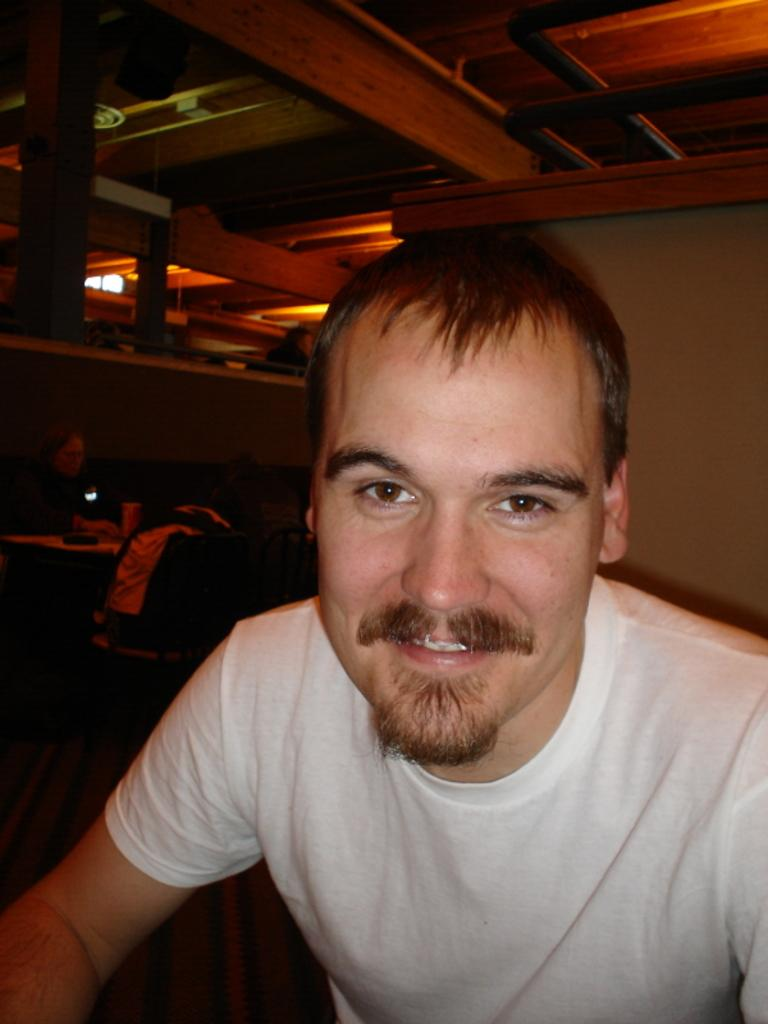What is the man in the image doing? The man in the image is smiling. What is the other person in the image doing? The other person is sitting in front of a table. What piece of furniture is present in the image? There is a bench in the image. What object can be seen in the image that might be used for carrying items? There is a bag in the image. What type of cow can be seen grazing in the background of the image? There is no cow present in the image; it only features a man, another person, a bench, and a bag. 